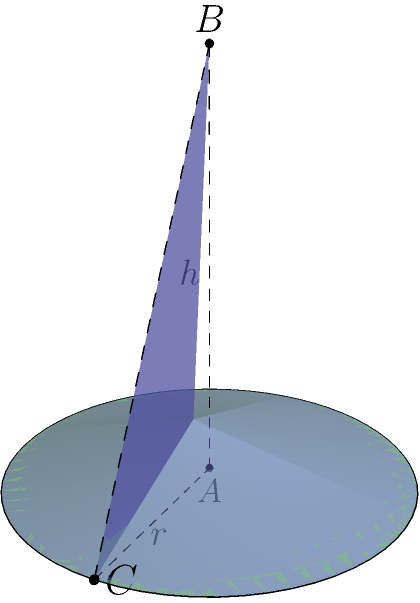As a math tutor, you're helping a student understand the concept of volume. Given a cone with radius $r = 2$ units and height $h = 4$ units, calculate its volume. Express your answer in terms of $\pi$ and simplify any fractions. Let's approach this step-by-step:

1) The formula for the volume of a cone is:

   $$V = \frac{1}{3}\pi r^2 h$$

   where $r$ is the radius of the base and $h$ is the height of the cone.

2) We're given:
   $r = 2$ units
   $h = 4$ units

3) Let's substitute these values into our formula:

   $$V = \frac{1}{3}\pi (2)^2 (4)$$

4) Simplify the expression inside the parentheses:

   $$V = \frac{1}{3}\pi (4) (4)$$

5) Multiply:

   $$V = \frac{1}{3}\pi (16)$$

6) Simplify:

   $$V = \frac{16}{3}\pi$$

Therefore, the volume of the cone is $\frac{16}{3}\pi$ cubic units.
Answer: $\frac{16}{3}\pi$ cubic units 